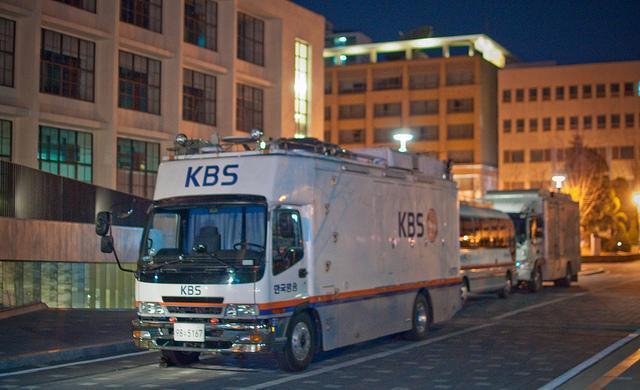How many vehicles can be seen?
Give a very brief answer. 3. How many trucks can be seen?
Give a very brief answer. 2. 